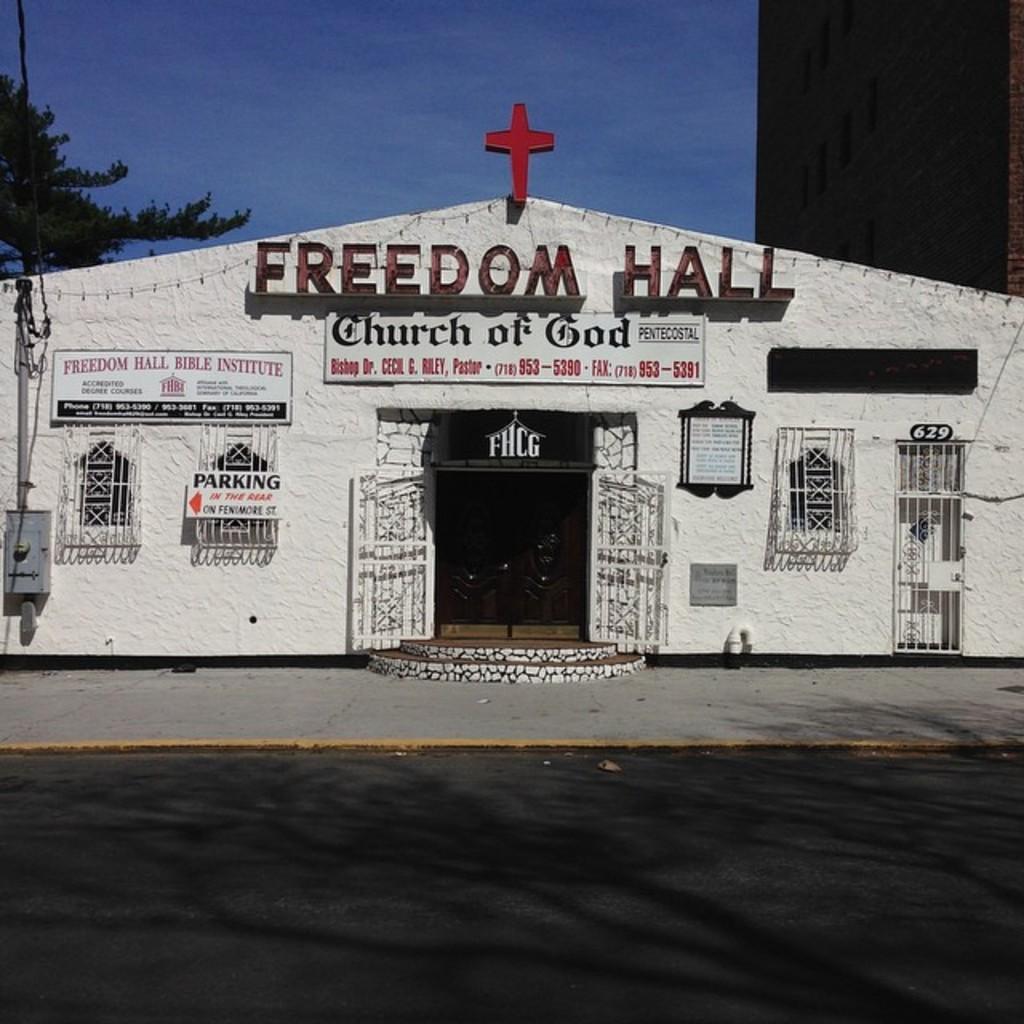Can you describe this image briefly? In the image we can see a building, on the building there are some banners. Behind the building there are some trees and clouds and sky. 